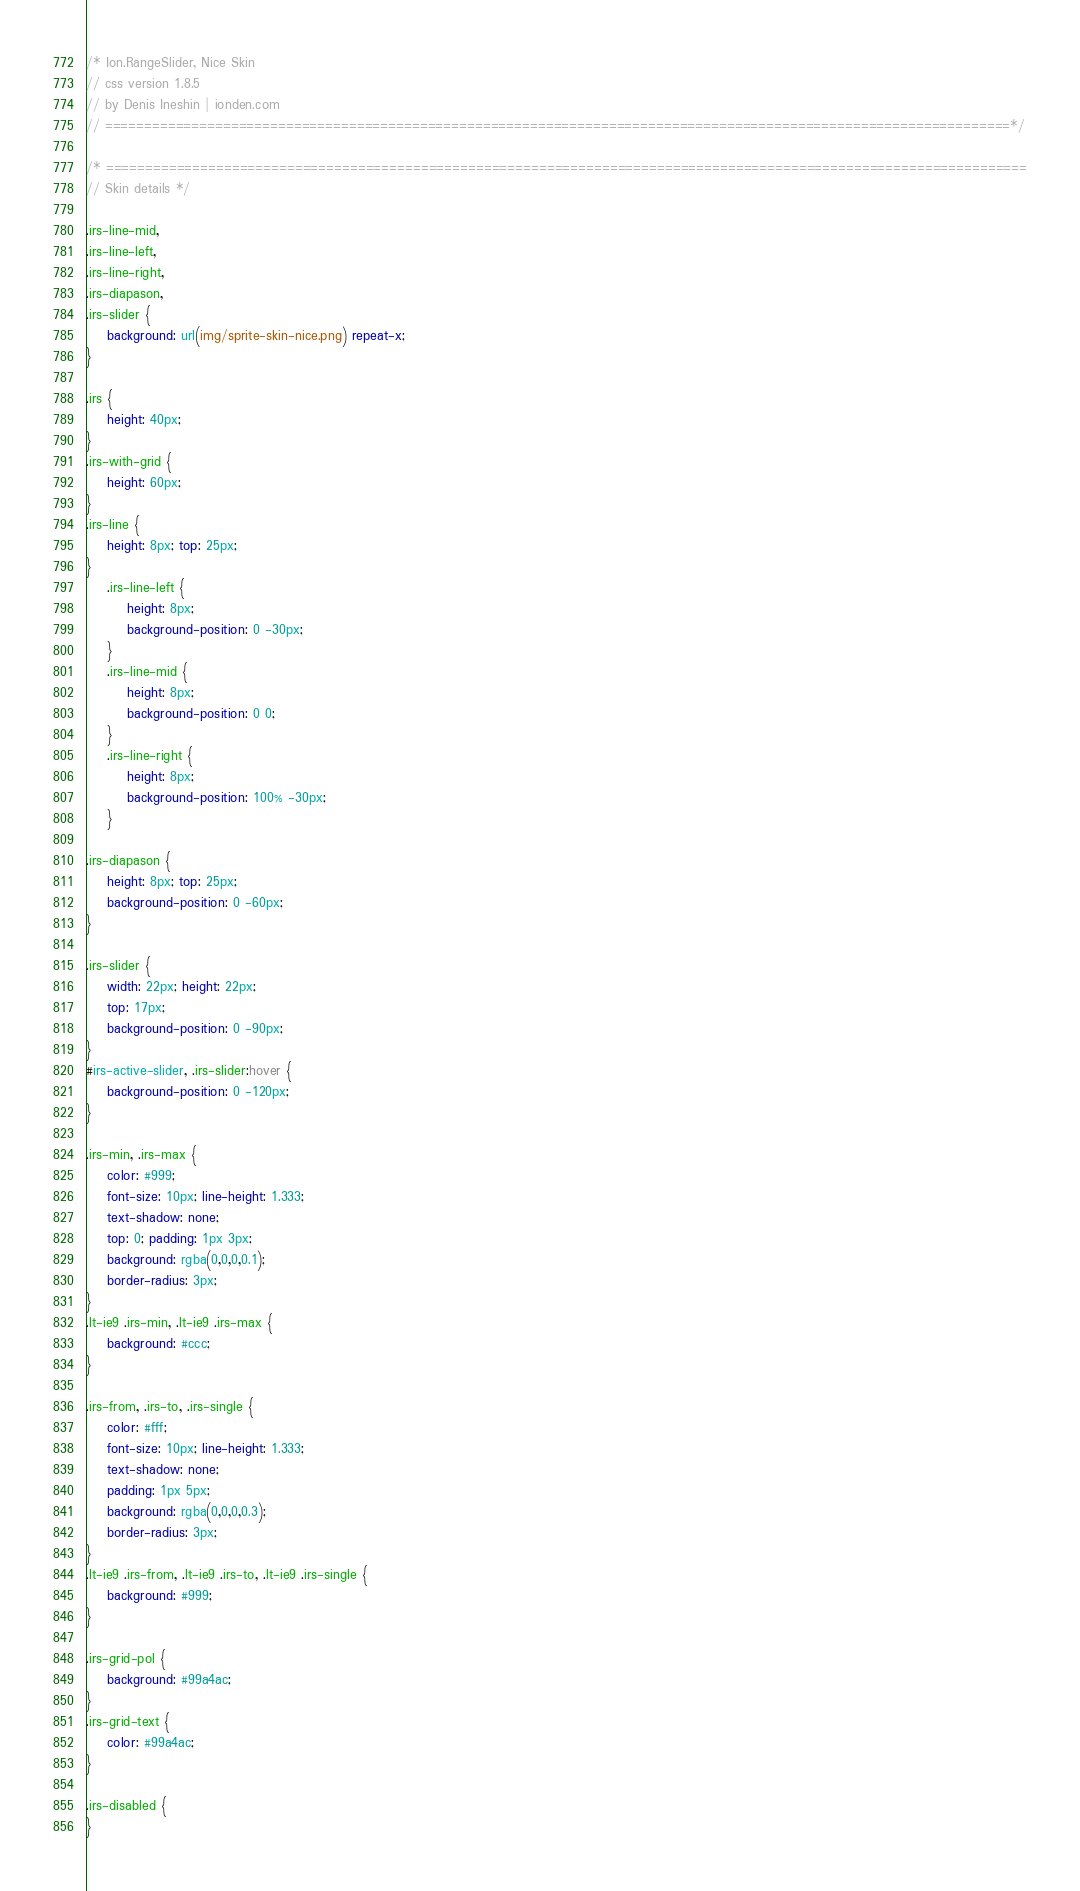<code> <loc_0><loc_0><loc_500><loc_500><_CSS_>/* Ion.RangeSlider, Nice Skin
// css version 1.8.5
// by Denis Ineshin | ionden.com
// ===================================================================================================================*/

/* =====================================================================================================================
// Skin details */

.irs-line-mid,
.irs-line-left,
.irs-line-right,
.irs-diapason,
.irs-slider {
    background: url(img/sprite-skin-nice.png) repeat-x;
}

.irs {
    height: 40px;
}
.irs-with-grid {
    height: 60px;
}
.irs-line {
    height: 8px; top: 25px;
}
    .irs-line-left {
        height: 8px;
        background-position: 0 -30px;
    }
    .irs-line-mid {
        height: 8px;
        background-position: 0 0;
    }
    .irs-line-right {
        height: 8px;
        background-position: 100% -30px;
    }

.irs-diapason {
    height: 8px; top: 25px;
    background-position: 0 -60px;
}

.irs-slider {
    width: 22px; height: 22px;
    top: 17px;
    background-position: 0 -90px;
}
#irs-active-slider, .irs-slider:hover {
    background-position: 0 -120px;
}

.irs-min, .irs-max {
    color: #999;
    font-size: 10px; line-height: 1.333;
    text-shadow: none;
    top: 0; padding: 1px 3px;
    background: rgba(0,0,0,0.1);
    border-radius: 3px;
}
.lt-ie9 .irs-min, .lt-ie9 .irs-max {
    background: #ccc;
}

.irs-from, .irs-to, .irs-single {
    color: #fff;
    font-size: 10px; line-height: 1.333;
    text-shadow: none;
    padding: 1px 5px;
    background: rgba(0,0,0,0.3);
    border-radius: 3px;
}
.lt-ie9 .irs-from, .lt-ie9 .irs-to, .lt-ie9 .irs-single {
    background: #999;
}

.irs-grid-pol {
    background: #99a4ac;
}
.irs-grid-text {
    color: #99a4ac;
}

.irs-disabled {
}
</code> 